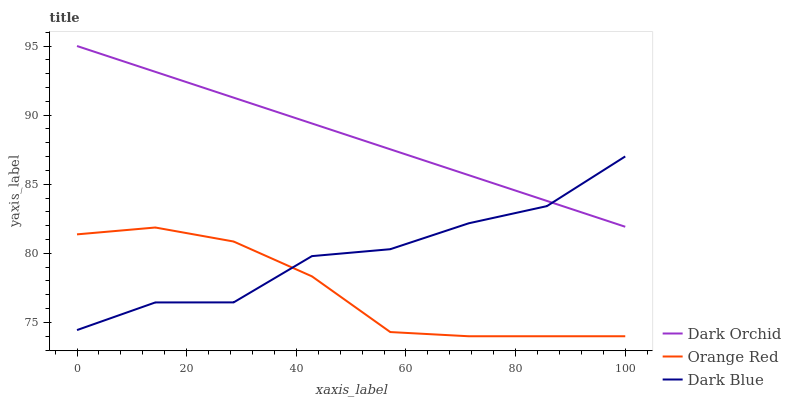Does Orange Red have the minimum area under the curve?
Answer yes or no. Yes. Does Dark Orchid have the maximum area under the curve?
Answer yes or no. Yes. Does Dark Orchid have the minimum area under the curve?
Answer yes or no. No. Does Orange Red have the maximum area under the curve?
Answer yes or no. No. Is Dark Orchid the smoothest?
Answer yes or no. Yes. Is Dark Blue the roughest?
Answer yes or no. Yes. Is Orange Red the smoothest?
Answer yes or no. No. Is Orange Red the roughest?
Answer yes or no. No. Does Orange Red have the lowest value?
Answer yes or no. Yes. Does Dark Orchid have the lowest value?
Answer yes or no. No. Does Dark Orchid have the highest value?
Answer yes or no. Yes. Does Orange Red have the highest value?
Answer yes or no. No. Is Orange Red less than Dark Orchid?
Answer yes or no. Yes. Is Dark Orchid greater than Orange Red?
Answer yes or no. Yes. Does Dark Blue intersect Dark Orchid?
Answer yes or no. Yes. Is Dark Blue less than Dark Orchid?
Answer yes or no. No. Is Dark Blue greater than Dark Orchid?
Answer yes or no. No. Does Orange Red intersect Dark Orchid?
Answer yes or no. No. 